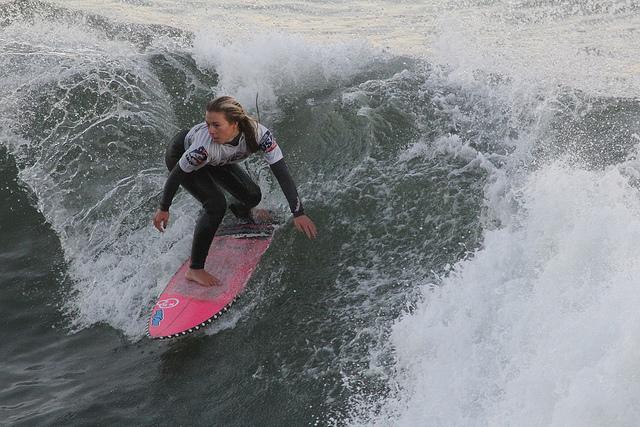Where is the wetsuit?
Write a very short answer. On woman. Is her back showing?
Keep it brief. No. What colors make up the board?
Quick response, please. Pink and blue. What hairstyle does the surfer have?
Concise answer only. Ponytail. What color is the surfboard?
Concise answer only. Pink. What is the person doing here?
Short answer required. Surfing. How old is the surfer?
Answer briefly. 23. Does the surfer have a swimsuit on?
Quick response, please. Yes. What gender is the person on the board?
Quick response, please. Female. Is the person a man?
Answer briefly. No. The person is a woman?
Answer briefly. Yes. Is a man or a woman swimming?
Concise answer only. No. What hairstyle is she wearing?
Keep it brief. Ponytail. 